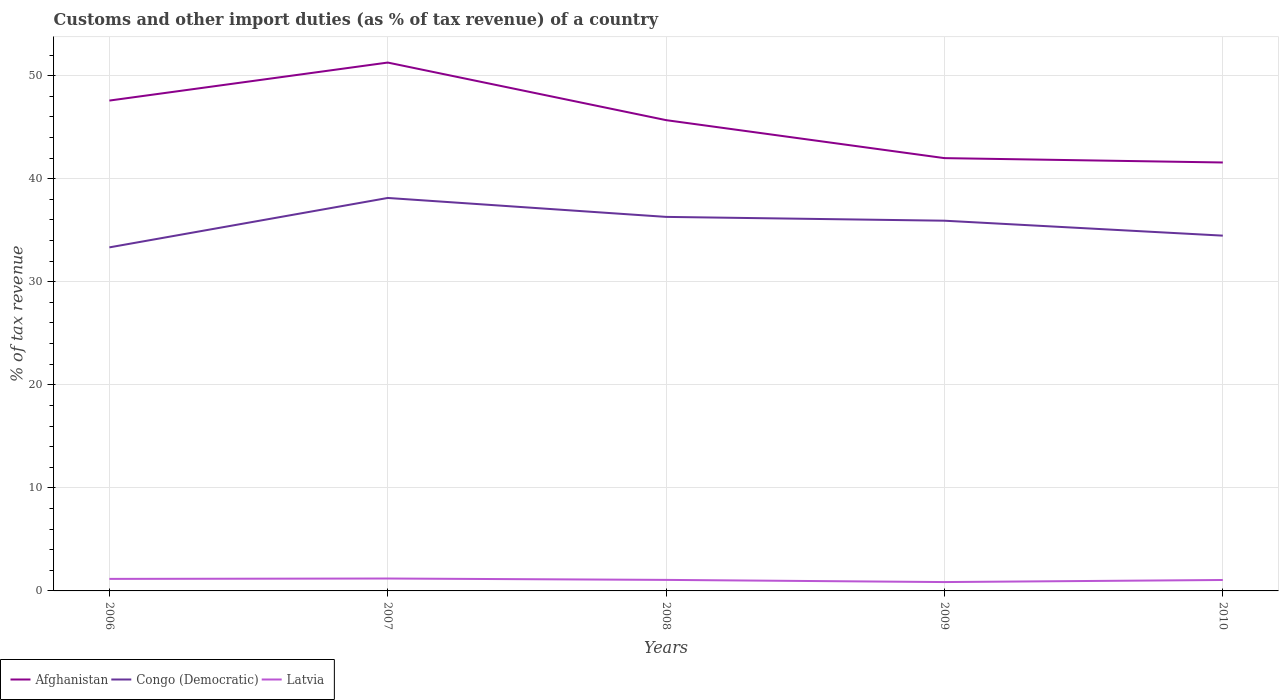How many different coloured lines are there?
Your answer should be compact. 3. Across all years, what is the maximum percentage of tax revenue from customs in Congo (Democratic)?
Provide a succinct answer. 33.34. In which year was the percentage of tax revenue from customs in Afghanistan maximum?
Provide a succinct answer. 2010. What is the total percentage of tax revenue from customs in Latvia in the graph?
Make the answer very short. 0.14. What is the difference between the highest and the second highest percentage of tax revenue from customs in Afghanistan?
Offer a very short reply. 9.7. What is the difference between the highest and the lowest percentage of tax revenue from customs in Afghanistan?
Offer a terse response. 3. Is the percentage of tax revenue from customs in Congo (Democratic) strictly greater than the percentage of tax revenue from customs in Latvia over the years?
Your answer should be compact. No. How many years are there in the graph?
Provide a short and direct response. 5. What is the difference between two consecutive major ticks on the Y-axis?
Make the answer very short. 10. Are the values on the major ticks of Y-axis written in scientific E-notation?
Offer a terse response. No. Does the graph contain any zero values?
Your answer should be compact. No. Where does the legend appear in the graph?
Your answer should be very brief. Bottom left. How many legend labels are there?
Ensure brevity in your answer.  3. What is the title of the graph?
Offer a very short reply. Customs and other import duties (as % of tax revenue) of a country. Does "Montenegro" appear as one of the legend labels in the graph?
Keep it short and to the point. No. What is the label or title of the X-axis?
Provide a succinct answer. Years. What is the label or title of the Y-axis?
Make the answer very short. % of tax revenue. What is the % of tax revenue in Afghanistan in 2006?
Make the answer very short. 47.58. What is the % of tax revenue of Congo (Democratic) in 2006?
Give a very brief answer. 33.34. What is the % of tax revenue of Latvia in 2006?
Give a very brief answer. 1.17. What is the % of tax revenue of Afghanistan in 2007?
Your answer should be compact. 51.27. What is the % of tax revenue in Congo (Democratic) in 2007?
Ensure brevity in your answer.  38.13. What is the % of tax revenue of Latvia in 2007?
Offer a terse response. 1.2. What is the % of tax revenue of Afghanistan in 2008?
Give a very brief answer. 45.68. What is the % of tax revenue of Congo (Democratic) in 2008?
Provide a succinct answer. 36.29. What is the % of tax revenue in Latvia in 2008?
Your response must be concise. 1.07. What is the % of tax revenue of Afghanistan in 2009?
Offer a terse response. 41.99. What is the % of tax revenue of Congo (Democratic) in 2009?
Your answer should be compact. 35.92. What is the % of tax revenue of Latvia in 2009?
Provide a short and direct response. 0.86. What is the % of tax revenue in Afghanistan in 2010?
Keep it short and to the point. 41.57. What is the % of tax revenue in Congo (Democratic) in 2010?
Provide a succinct answer. 34.47. What is the % of tax revenue in Latvia in 2010?
Ensure brevity in your answer.  1.06. Across all years, what is the maximum % of tax revenue in Afghanistan?
Make the answer very short. 51.27. Across all years, what is the maximum % of tax revenue of Congo (Democratic)?
Your response must be concise. 38.13. Across all years, what is the maximum % of tax revenue of Latvia?
Provide a short and direct response. 1.2. Across all years, what is the minimum % of tax revenue in Afghanistan?
Offer a very short reply. 41.57. Across all years, what is the minimum % of tax revenue of Congo (Democratic)?
Ensure brevity in your answer.  33.34. Across all years, what is the minimum % of tax revenue in Latvia?
Offer a terse response. 0.86. What is the total % of tax revenue of Afghanistan in the graph?
Provide a short and direct response. 228.1. What is the total % of tax revenue in Congo (Democratic) in the graph?
Your response must be concise. 178.16. What is the total % of tax revenue in Latvia in the graph?
Offer a terse response. 5.36. What is the difference between the % of tax revenue in Afghanistan in 2006 and that in 2007?
Provide a succinct answer. -3.69. What is the difference between the % of tax revenue of Congo (Democratic) in 2006 and that in 2007?
Provide a succinct answer. -4.8. What is the difference between the % of tax revenue of Latvia in 2006 and that in 2007?
Your response must be concise. -0.04. What is the difference between the % of tax revenue of Afghanistan in 2006 and that in 2008?
Your response must be concise. 1.9. What is the difference between the % of tax revenue in Congo (Democratic) in 2006 and that in 2008?
Your answer should be very brief. -2.96. What is the difference between the % of tax revenue in Latvia in 2006 and that in 2008?
Offer a very short reply. 0.1. What is the difference between the % of tax revenue of Afghanistan in 2006 and that in 2009?
Offer a very short reply. 5.59. What is the difference between the % of tax revenue in Congo (Democratic) in 2006 and that in 2009?
Provide a short and direct response. -2.59. What is the difference between the % of tax revenue in Latvia in 2006 and that in 2009?
Your response must be concise. 0.31. What is the difference between the % of tax revenue in Afghanistan in 2006 and that in 2010?
Make the answer very short. 6.01. What is the difference between the % of tax revenue in Congo (Democratic) in 2006 and that in 2010?
Provide a short and direct response. -1.14. What is the difference between the % of tax revenue of Latvia in 2006 and that in 2010?
Provide a succinct answer. 0.11. What is the difference between the % of tax revenue of Afghanistan in 2007 and that in 2008?
Keep it short and to the point. 5.59. What is the difference between the % of tax revenue of Congo (Democratic) in 2007 and that in 2008?
Your answer should be compact. 1.84. What is the difference between the % of tax revenue of Latvia in 2007 and that in 2008?
Offer a very short reply. 0.13. What is the difference between the % of tax revenue in Afghanistan in 2007 and that in 2009?
Make the answer very short. 9.27. What is the difference between the % of tax revenue in Congo (Democratic) in 2007 and that in 2009?
Your response must be concise. 2.21. What is the difference between the % of tax revenue of Latvia in 2007 and that in 2009?
Keep it short and to the point. 0.34. What is the difference between the % of tax revenue of Afghanistan in 2007 and that in 2010?
Provide a short and direct response. 9.7. What is the difference between the % of tax revenue in Congo (Democratic) in 2007 and that in 2010?
Offer a terse response. 3.66. What is the difference between the % of tax revenue in Latvia in 2007 and that in 2010?
Make the answer very short. 0.14. What is the difference between the % of tax revenue in Afghanistan in 2008 and that in 2009?
Make the answer very short. 3.69. What is the difference between the % of tax revenue in Congo (Democratic) in 2008 and that in 2009?
Offer a terse response. 0.37. What is the difference between the % of tax revenue in Latvia in 2008 and that in 2009?
Ensure brevity in your answer.  0.21. What is the difference between the % of tax revenue in Afghanistan in 2008 and that in 2010?
Give a very brief answer. 4.11. What is the difference between the % of tax revenue of Congo (Democratic) in 2008 and that in 2010?
Give a very brief answer. 1.82. What is the difference between the % of tax revenue in Latvia in 2008 and that in 2010?
Ensure brevity in your answer.  0.01. What is the difference between the % of tax revenue in Afghanistan in 2009 and that in 2010?
Provide a succinct answer. 0.42. What is the difference between the % of tax revenue in Congo (Democratic) in 2009 and that in 2010?
Keep it short and to the point. 1.45. What is the difference between the % of tax revenue of Latvia in 2009 and that in 2010?
Offer a very short reply. -0.2. What is the difference between the % of tax revenue of Afghanistan in 2006 and the % of tax revenue of Congo (Democratic) in 2007?
Keep it short and to the point. 9.45. What is the difference between the % of tax revenue of Afghanistan in 2006 and the % of tax revenue of Latvia in 2007?
Offer a very short reply. 46.38. What is the difference between the % of tax revenue of Congo (Democratic) in 2006 and the % of tax revenue of Latvia in 2007?
Your answer should be very brief. 32.13. What is the difference between the % of tax revenue in Afghanistan in 2006 and the % of tax revenue in Congo (Democratic) in 2008?
Your response must be concise. 11.29. What is the difference between the % of tax revenue in Afghanistan in 2006 and the % of tax revenue in Latvia in 2008?
Your response must be concise. 46.51. What is the difference between the % of tax revenue of Congo (Democratic) in 2006 and the % of tax revenue of Latvia in 2008?
Give a very brief answer. 32.27. What is the difference between the % of tax revenue in Afghanistan in 2006 and the % of tax revenue in Congo (Democratic) in 2009?
Your response must be concise. 11.66. What is the difference between the % of tax revenue of Afghanistan in 2006 and the % of tax revenue of Latvia in 2009?
Make the answer very short. 46.72. What is the difference between the % of tax revenue in Congo (Democratic) in 2006 and the % of tax revenue in Latvia in 2009?
Provide a short and direct response. 32.48. What is the difference between the % of tax revenue in Afghanistan in 2006 and the % of tax revenue in Congo (Democratic) in 2010?
Ensure brevity in your answer.  13.11. What is the difference between the % of tax revenue in Afghanistan in 2006 and the % of tax revenue in Latvia in 2010?
Your response must be concise. 46.52. What is the difference between the % of tax revenue in Congo (Democratic) in 2006 and the % of tax revenue in Latvia in 2010?
Provide a short and direct response. 32.27. What is the difference between the % of tax revenue of Afghanistan in 2007 and the % of tax revenue of Congo (Democratic) in 2008?
Provide a succinct answer. 14.98. What is the difference between the % of tax revenue in Afghanistan in 2007 and the % of tax revenue in Latvia in 2008?
Your response must be concise. 50.2. What is the difference between the % of tax revenue of Congo (Democratic) in 2007 and the % of tax revenue of Latvia in 2008?
Ensure brevity in your answer.  37.06. What is the difference between the % of tax revenue of Afghanistan in 2007 and the % of tax revenue of Congo (Democratic) in 2009?
Offer a terse response. 15.35. What is the difference between the % of tax revenue in Afghanistan in 2007 and the % of tax revenue in Latvia in 2009?
Give a very brief answer. 50.41. What is the difference between the % of tax revenue of Congo (Democratic) in 2007 and the % of tax revenue of Latvia in 2009?
Provide a succinct answer. 37.27. What is the difference between the % of tax revenue of Afghanistan in 2007 and the % of tax revenue of Congo (Democratic) in 2010?
Provide a succinct answer. 16.8. What is the difference between the % of tax revenue in Afghanistan in 2007 and the % of tax revenue in Latvia in 2010?
Give a very brief answer. 50.21. What is the difference between the % of tax revenue of Congo (Democratic) in 2007 and the % of tax revenue of Latvia in 2010?
Your answer should be compact. 37.07. What is the difference between the % of tax revenue of Afghanistan in 2008 and the % of tax revenue of Congo (Democratic) in 2009?
Provide a succinct answer. 9.76. What is the difference between the % of tax revenue of Afghanistan in 2008 and the % of tax revenue of Latvia in 2009?
Your answer should be compact. 44.82. What is the difference between the % of tax revenue in Congo (Democratic) in 2008 and the % of tax revenue in Latvia in 2009?
Your answer should be compact. 35.43. What is the difference between the % of tax revenue in Afghanistan in 2008 and the % of tax revenue in Congo (Democratic) in 2010?
Make the answer very short. 11.21. What is the difference between the % of tax revenue in Afghanistan in 2008 and the % of tax revenue in Latvia in 2010?
Your answer should be very brief. 44.62. What is the difference between the % of tax revenue in Congo (Democratic) in 2008 and the % of tax revenue in Latvia in 2010?
Your response must be concise. 35.23. What is the difference between the % of tax revenue in Afghanistan in 2009 and the % of tax revenue in Congo (Democratic) in 2010?
Your answer should be compact. 7.52. What is the difference between the % of tax revenue in Afghanistan in 2009 and the % of tax revenue in Latvia in 2010?
Give a very brief answer. 40.93. What is the difference between the % of tax revenue in Congo (Democratic) in 2009 and the % of tax revenue in Latvia in 2010?
Ensure brevity in your answer.  34.86. What is the average % of tax revenue in Afghanistan per year?
Keep it short and to the point. 45.62. What is the average % of tax revenue in Congo (Democratic) per year?
Your answer should be compact. 35.63. What is the average % of tax revenue in Latvia per year?
Ensure brevity in your answer.  1.07. In the year 2006, what is the difference between the % of tax revenue in Afghanistan and % of tax revenue in Congo (Democratic)?
Ensure brevity in your answer.  14.24. In the year 2006, what is the difference between the % of tax revenue of Afghanistan and % of tax revenue of Latvia?
Offer a terse response. 46.41. In the year 2006, what is the difference between the % of tax revenue of Congo (Democratic) and % of tax revenue of Latvia?
Keep it short and to the point. 32.17. In the year 2007, what is the difference between the % of tax revenue in Afghanistan and % of tax revenue in Congo (Democratic)?
Ensure brevity in your answer.  13.14. In the year 2007, what is the difference between the % of tax revenue of Afghanistan and % of tax revenue of Latvia?
Your answer should be very brief. 50.07. In the year 2007, what is the difference between the % of tax revenue of Congo (Democratic) and % of tax revenue of Latvia?
Your answer should be very brief. 36.93. In the year 2008, what is the difference between the % of tax revenue of Afghanistan and % of tax revenue of Congo (Democratic)?
Offer a terse response. 9.39. In the year 2008, what is the difference between the % of tax revenue in Afghanistan and % of tax revenue in Latvia?
Give a very brief answer. 44.61. In the year 2008, what is the difference between the % of tax revenue of Congo (Democratic) and % of tax revenue of Latvia?
Offer a very short reply. 35.22. In the year 2009, what is the difference between the % of tax revenue in Afghanistan and % of tax revenue in Congo (Democratic)?
Provide a short and direct response. 6.07. In the year 2009, what is the difference between the % of tax revenue in Afghanistan and % of tax revenue in Latvia?
Your response must be concise. 41.14. In the year 2009, what is the difference between the % of tax revenue of Congo (Democratic) and % of tax revenue of Latvia?
Provide a short and direct response. 35.06. In the year 2010, what is the difference between the % of tax revenue of Afghanistan and % of tax revenue of Congo (Democratic)?
Your response must be concise. 7.1. In the year 2010, what is the difference between the % of tax revenue in Afghanistan and % of tax revenue in Latvia?
Offer a very short reply. 40.51. In the year 2010, what is the difference between the % of tax revenue in Congo (Democratic) and % of tax revenue in Latvia?
Give a very brief answer. 33.41. What is the ratio of the % of tax revenue in Afghanistan in 2006 to that in 2007?
Your answer should be compact. 0.93. What is the ratio of the % of tax revenue in Congo (Democratic) in 2006 to that in 2007?
Offer a very short reply. 0.87. What is the ratio of the % of tax revenue in Latvia in 2006 to that in 2007?
Provide a short and direct response. 0.97. What is the ratio of the % of tax revenue in Afghanistan in 2006 to that in 2008?
Your answer should be compact. 1.04. What is the ratio of the % of tax revenue in Congo (Democratic) in 2006 to that in 2008?
Give a very brief answer. 0.92. What is the ratio of the % of tax revenue of Latvia in 2006 to that in 2008?
Your answer should be compact. 1.09. What is the ratio of the % of tax revenue in Afghanistan in 2006 to that in 2009?
Provide a succinct answer. 1.13. What is the ratio of the % of tax revenue of Congo (Democratic) in 2006 to that in 2009?
Give a very brief answer. 0.93. What is the ratio of the % of tax revenue of Latvia in 2006 to that in 2009?
Offer a terse response. 1.36. What is the ratio of the % of tax revenue in Afghanistan in 2006 to that in 2010?
Offer a very short reply. 1.14. What is the ratio of the % of tax revenue of Congo (Democratic) in 2006 to that in 2010?
Your response must be concise. 0.97. What is the ratio of the % of tax revenue of Latvia in 2006 to that in 2010?
Your answer should be compact. 1.1. What is the ratio of the % of tax revenue of Afghanistan in 2007 to that in 2008?
Your answer should be very brief. 1.12. What is the ratio of the % of tax revenue in Congo (Democratic) in 2007 to that in 2008?
Give a very brief answer. 1.05. What is the ratio of the % of tax revenue in Latvia in 2007 to that in 2008?
Provide a short and direct response. 1.13. What is the ratio of the % of tax revenue in Afghanistan in 2007 to that in 2009?
Ensure brevity in your answer.  1.22. What is the ratio of the % of tax revenue in Congo (Democratic) in 2007 to that in 2009?
Ensure brevity in your answer.  1.06. What is the ratio of the % of tax revenue of Latvia in 2007 to that in 2009?
Offer a terse response. 1.4. What is the ratio of the % of tax revenue of Afghanistan in 2007 to that in 2010?
Your answer should be very brief. 1.23. What is the ratio of the % of tax revenue of Congo (Democratic) in 2007 to that in 2010?
Provide a succinct answer. 1.11. What is the ratio of the % of tax revenue in Latvia in 2007 to that in 2010?
Give a very brief answer. 1.13. What is the ratio of the % of tax revenue of Afghanistan in 2008 to that in 2009?
Keep it short and to the point. 1.09. What is the ratio of the % of tax revenue in Congo (Democratic) in 2008 to that in 2009?
Your answer should be very brief. 1.01. What is the ratio of the % of tax revenue in Latvia in 2008 to that in 2009?
Provide a succinct answer. 1.25. What is the ratio of the % of tax revenue of Afghanistan in 2008 to that in 2010?
Your answer should be very brief. 1.1. What is the ratio of the % of tax revenue in Congo (Democratic) in 2008 to that in 2010?
Your response must be concise. 1.05. What is the ratio of the % of tax revenue of Latvia in 2008 to that in 2010?
Offer a very short reply. 1.01. What is the ratio of the % of tax revenue of Afghanistan in 2009 to that in 2010?
Provide a short and direct response. 1.01. What is the ratio of the % of tax revenue in Congo (Democratic) in 2009 to that in 2010?
Your response must be concise. 1.04. What is the ratio of the % of tax revenue in Latvia in 2009 to that in 2010?
Offer a very short reply. 0.81. What is the difference between the highest and the second highest % of tax revenue of Afghanistan?
Offer a very short reply. 3.69. What is the difference between the highest and the second highest % of tax revenue of Congo (Democratic)?
Keep it short and to the point. 1.84. What is the difference between the highest and the second highest % of tax revenue in Latvia?
Offer a very short reply. 0.04. What is the difference between the highest and the lowest % of tax revenue of Afghanistan?
Your answer should be very brief. 9.7. What is the difference between the highest and the lowest % of tax revenue in Congo (Democratic)?
Provide a short and direct response. 4.8. What is the difference between the highest and the lowest % of tax revenue of Latvia?
Your answer should be very brief. 0.34. 